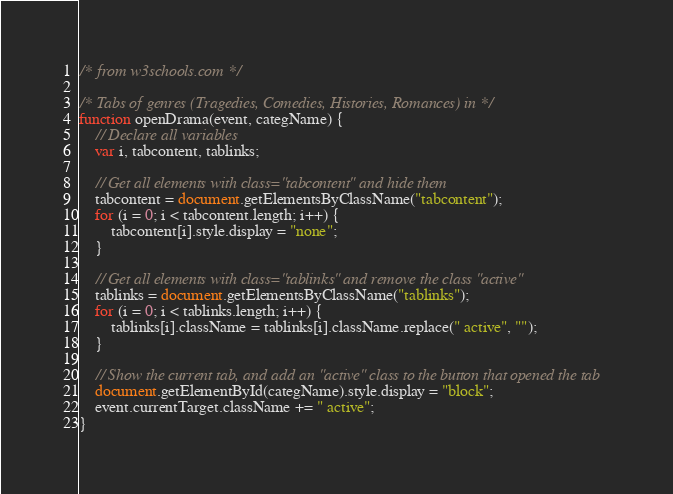Convert code to text. <code><loc_0><loc_0><loc_500><loc_500><_JavaScript_>/* from w3schools.com */

/* Tabs of genres (Tragedies, Comedies, Histories, Romances) in */
function openDrama(event, categName) {
    // Declare all variables
    var i, tabcontent, tablinks;

    // Get all elements with class="tabcontent" and hide them
    tabcontent = document.getElementsByClassName("tabcontent");
    for (i = 0; i < tabcontent.length; i++) {
        tabcontent[i].style.display = "none";
    }

    // Get all elements with class="tablinks" and remove the class "active"
    tablinks = document.getElementsByClassName("tablinks");
    for (i = 0; i < tablinks.length; i++) {
        tablinks[i].className = tablinks[i].className.replace(" active", "");
    }

    // Show the current tab, and add an "active" class to the button that opened the tab
    document.getElementById(categName).style.display = "block";
    event.currentTarget.className += " active";
}
</code> 